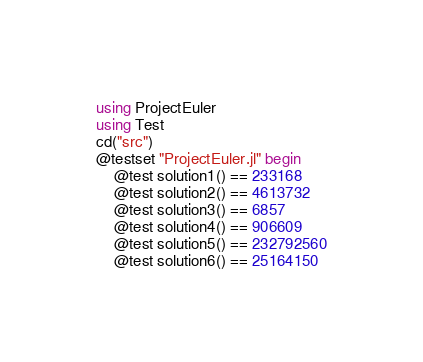Convert code to text. <code><loc_0><loc_0><loc_500><loc_500><_Julia_>using ProjectEuler
using Test
cd("src")
@testset "ProjectEuler.jl" begin
    @test solution1() == 233168
    @test solution2() == 4613732
    @test solution3() == 6857
    @test solution4() == 906609
    @test solution5() == 232792560
    @test solution6() == 25164150</code> 